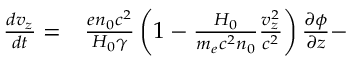<formula> <loc_0><loc_0><loc_500><loc_500>\begin{array} { r l } { \frac { d v _ { z } } { d t } = } & \frac { e n _ { 0 } c ^ { 2 } } { H _ { 0 } \gamma } \left ( 1 - \frac { H _ { 0 } } { m _ { e } c ^ { 2 } n _ { 0 } } \frac { v _ { z } ^ { 2 } } { c ^ { 2 } } \right ) \frac { \partial \phi } { \partial z } - } \end{array}</formula> 